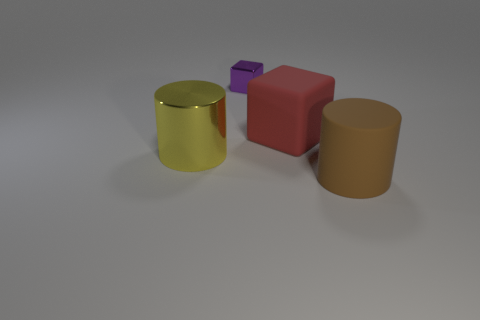Is the number of tiny purple metal cubes greater than the number of green rubber objects?
Your response must be concise. Yes. There is a thing that is behind the yellow metallic cylinder and to the left of the red rubber thing; what is its size?
Your answer should be very brief. Small. Are there the same number of large objects to the right of the big brown thing and red rubber blocks?
Offer a very short reply. No. Is the size of the matte cylinder the same as the red object?
Keep it short and to the point. Yes. There is a big thing that is in front of the large red cube and behind the large brown cylinder; what is its color?
Give a very brief answer. Yellow. There is a cylinder that is on the left side of the thing that is behind the big red object; what is it made of?
Offer a very short reply. Metal. There is another thing that is the same shape as the brown matte object; what is its size?
Give a very brief answer. Large. Is the number of large metal cylinders less than the number of small gray matte cylinders?
Your answer should be very brief. No. Do the object left of the tiny purple shiny thing and the brown cylinder have the same material?
Offer a very short reply. No. There is a cylinder that is right of the purple thing; what material is it?
Keep it short and to the point. Rubber. 